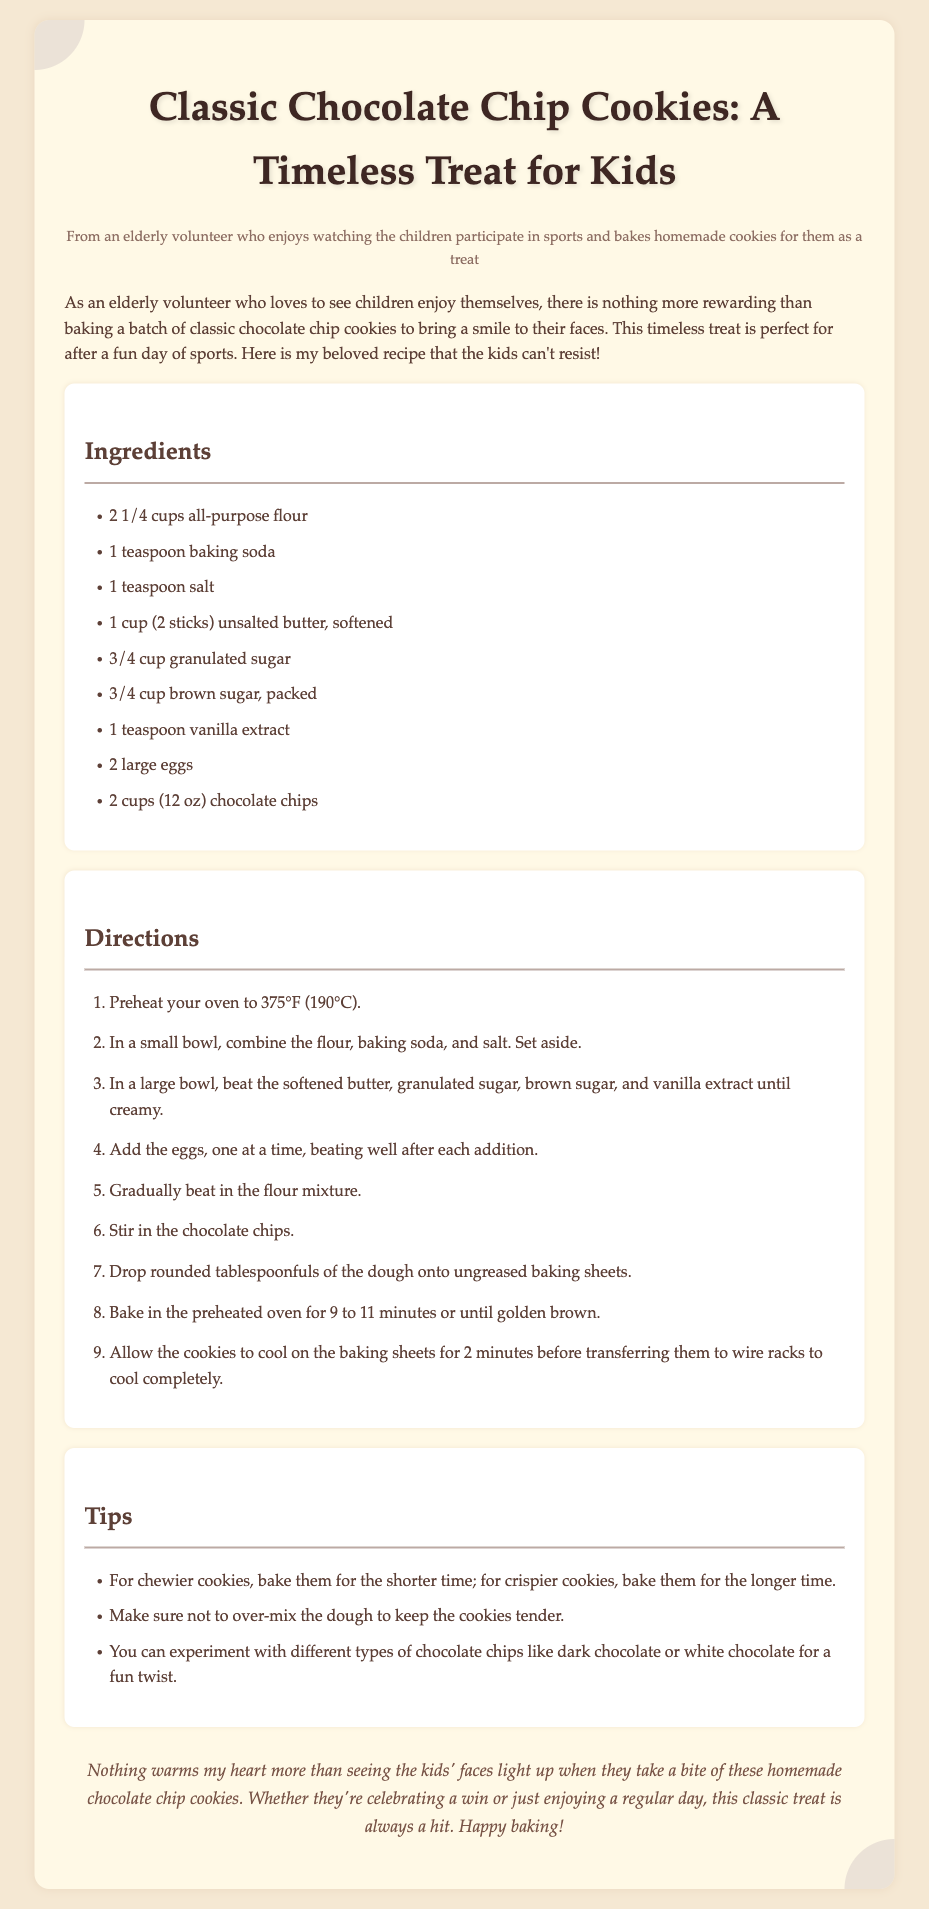What is the total amount of flour required? The recipe states that you need 2 1/4 cups of all-purpose flour.
Answer: 2 1/4 cups How long do you bake the cookies? The document mentions that you should bake the cookies for 9 to 11 minutes.
Answer: 9 to 11 minutes What type of sugar is used besides granulated sugar? The recipe lists brown sugar as the other type of sugar used.
Answer: Brown sugar What is the first step in the directions? The first direction instructs you to preheat your oven to 375°F (190°C).
Answer: Preheat your oven to 375°F (190°C) How many large eggs are needed for the recipe? The ingredients list states that you need 2 large eggs.
Answer: 2 large eggs What should you do to keep the cookies tender? The tips advise not to over-mix the dough to keep the cookies tender.
Answer: Not to over-mix the dough What can you add for a fun twist? The tips suggest experimenting with different types of chocolate chips.
Answer: Different types of chocolate chips What type of document is this? This document is a recipe card for making cookies.
Answer: Recipe card 